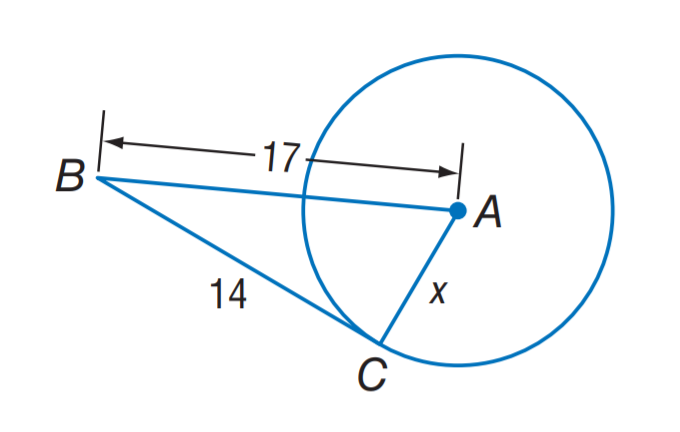Answer the mathemtical geometry problem and directly provide the correct option letter.
Question: Assume that the segment is tangent, find the value of x.
Choices: A: \sqrt { 14 } B: \sqrt { 17 } C: \sqrt { 93 } D: \sqrt { 485 } C 